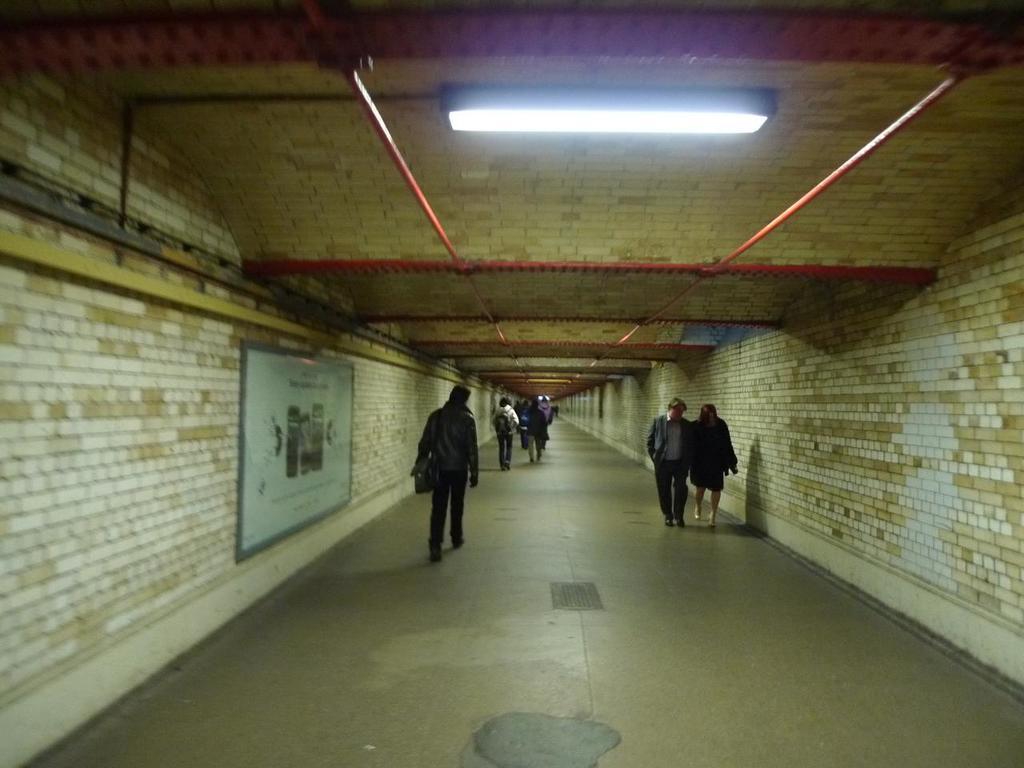How would you summarize this image in a sentence or two? This image is taken in a subway, which consists of a group of people walking and on the left wall there is a poster which has images and text, there are lights on the roof. 